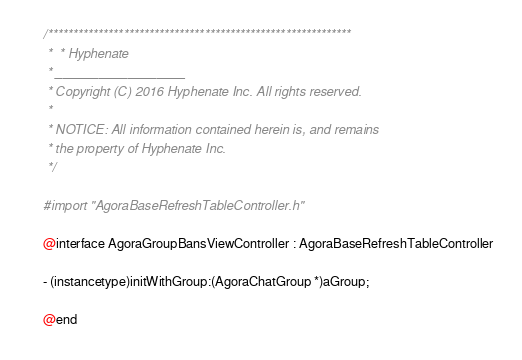Convert code to text. <code><loc_0><loc_0><loc_500><loc_500><_C_>/************************************************************
 *  * Hyphenate
 * __________________
 * Copyright (C) 2016 Hyphenate Inc. All rights reserved.
 *
 * NOTICE: All information contained herein is, and remains
 * the property of Hyphenate Inc.
 */

#import "AgoraBaseRefreshTableController.h"

@interface AgoraGroupBansViewController : AgoraBaseRefreshTableController

- (instancetype)initWithGroup:(AgoraChatGroup *)aGroup;

@end
</code> 